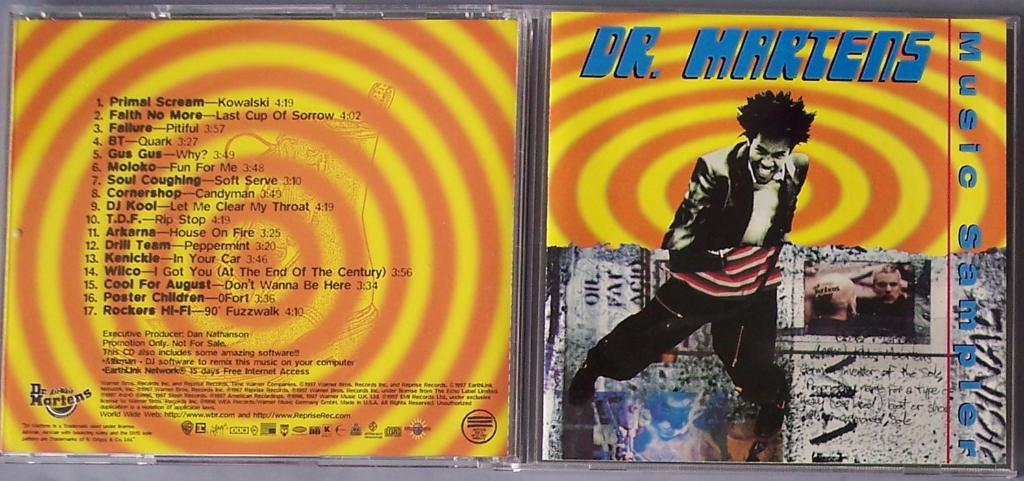<image>
Describe the image concisely. A compact disc cover is open of Dr. Martens music. 